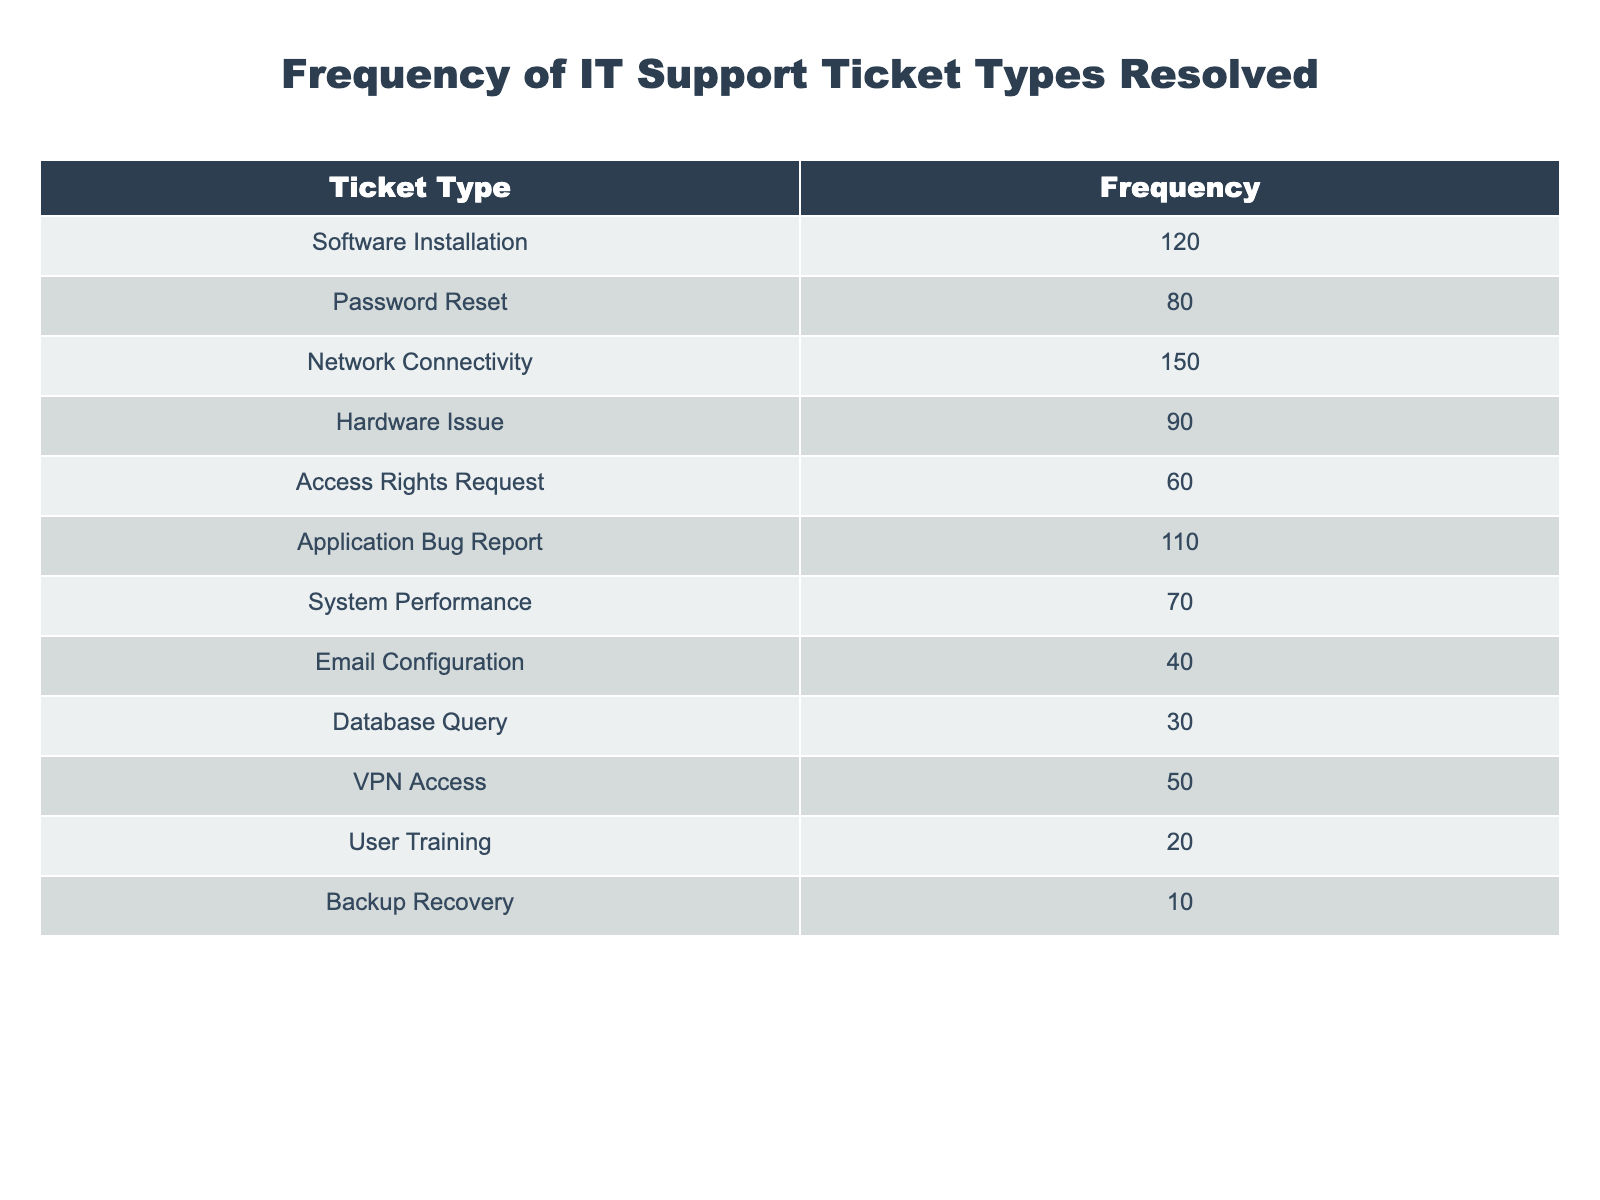What is the frequency of the Hardware Issue ticket type? The table lists a frequency of 90 under the Hardware Issue ticket type.
Answer: 90 What is the total frequency of ticket types related to Software and Application? The frequency of Software Installation is 120 and Application Bug Report is 110. Adding these frequencies together gives us 120 + 110 = 230.
Answer: 230 Is the frequency of Email Configuration ticket types greater than that of VPN Access? The frequency for Email Configuration is 40, while for VPN Access it is 50. Since 40 is not greater than 50, the answer is no.
Answer: No What is the ticket type with the highest frequency? Among the ticket types, Network Connectivity has the highest frequency at 150.
Answer: Network Connectivity What is the average frequency of all ticket types? First, we need to sum the frequencies: 120 + 80 + 150 + 90 + 60 + 110 + 70 + 40 + 30 + 50 + 20 + 10 = 1020. There are 12 ticket types, so we divide 1020 by 12, which gives us an average of 85.
Answer: 85 How many more tickets were resolved for Network Connectivity compared to User Training? The frequency for Network Connectivity is 150, and for User Training, it is 20. The difference is calculated as 150 - 20 = 130.
Answer: 130 What percentage of the total tickets were Password Reset types? The frequency for Password Reset is 80. The total frequency is 1020. We calculate the percentage by (80 / 1020) * 100, which is approximately 7.84%.
Answer: 7.84% Is there a ticket type that has a frequency of less than 20? From the table, the lowest frequency is for Backup Recovery at 10, which is less than 20, so the answer is yes.
Answer: Yes Which ticket type has a frequency closest to 60? The Access Rights Request ticket type has a frequency of 60, which is exactly 60; all other ticket types are either higher or lower.
Answer: Access Rights Request 